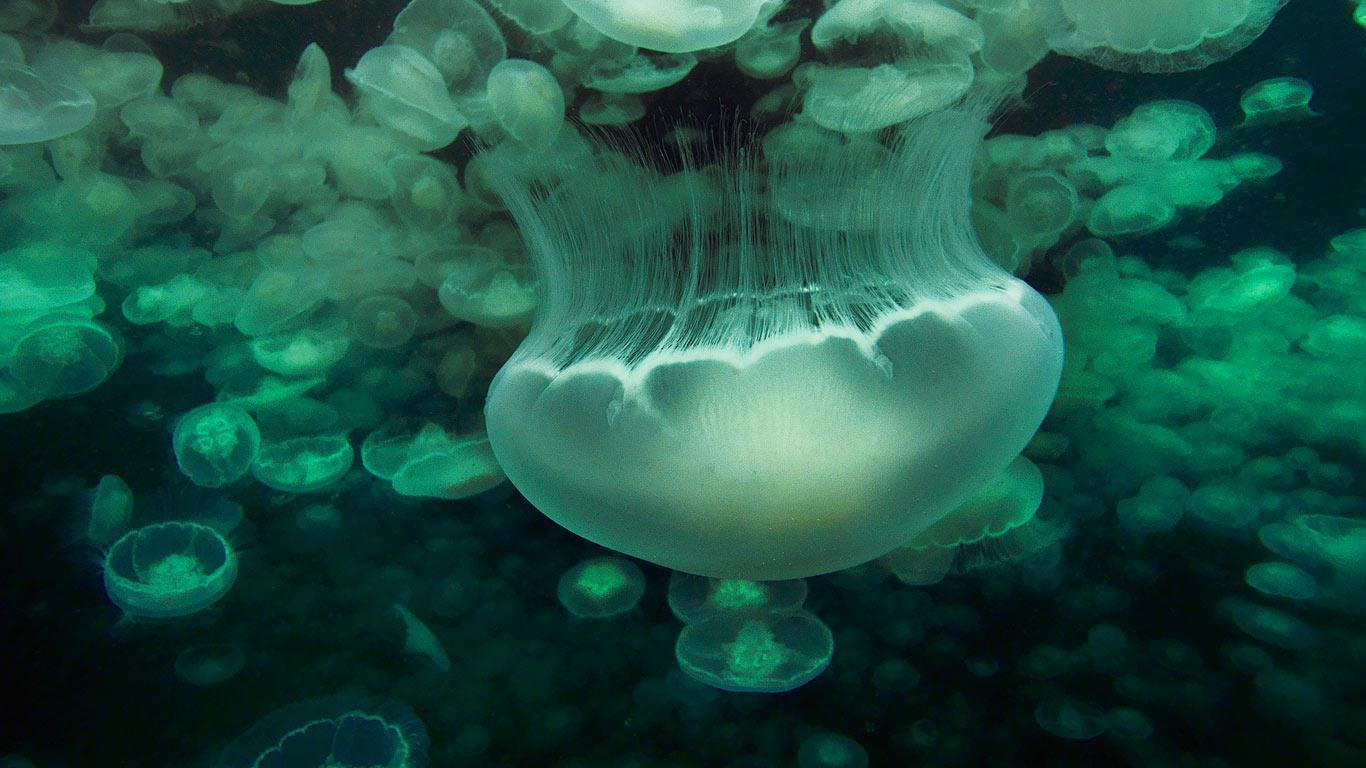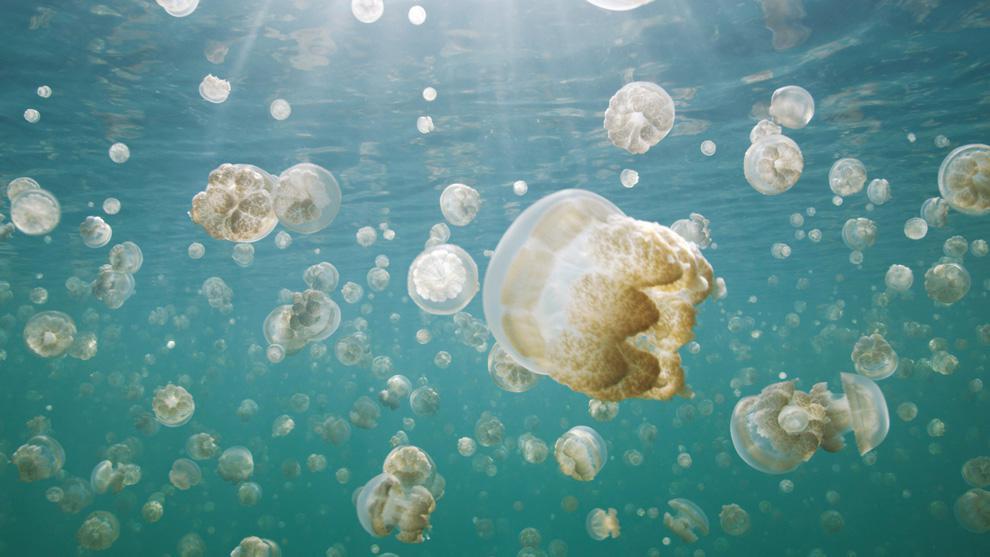The first image is the image on the left, the second image is the image on the right. Assess this claim about the two images: "There is a single jellyfish in the image on the left". Correct or not? Answer yes or no. No. The first image is the image on the left, the second image is the image on the right. Analyze the images presented: Is the assertion "Left image shows a prominent jellyfish in foreground with many smaller jellyfish in the background." valid? Answer yes or no. Yes. 